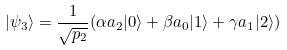<formula> <loc_0><loc_0><loc_500><loc_500>| \psi _ { 3 } \rangle = \frac { 1 } { \sqrt { p _ { 2 } } } ( \alpha a _ { 2 } | 0 \rangle + \beta a _ { 0 } | 1 \rangle + \gamma a _ { 1 } | 2 \rangle )</formula> 